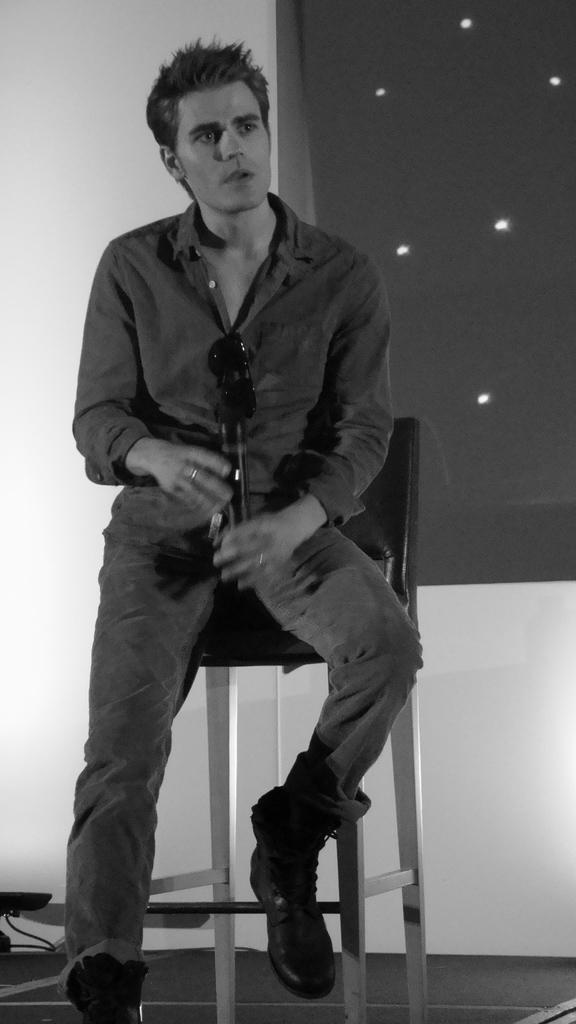How would you summarize this image in a sentence or two? In this image I can see a person is sitting on a chair and is holding a mike in hand. In the background I can see a wall and window. This image is taken may be in a hall. 